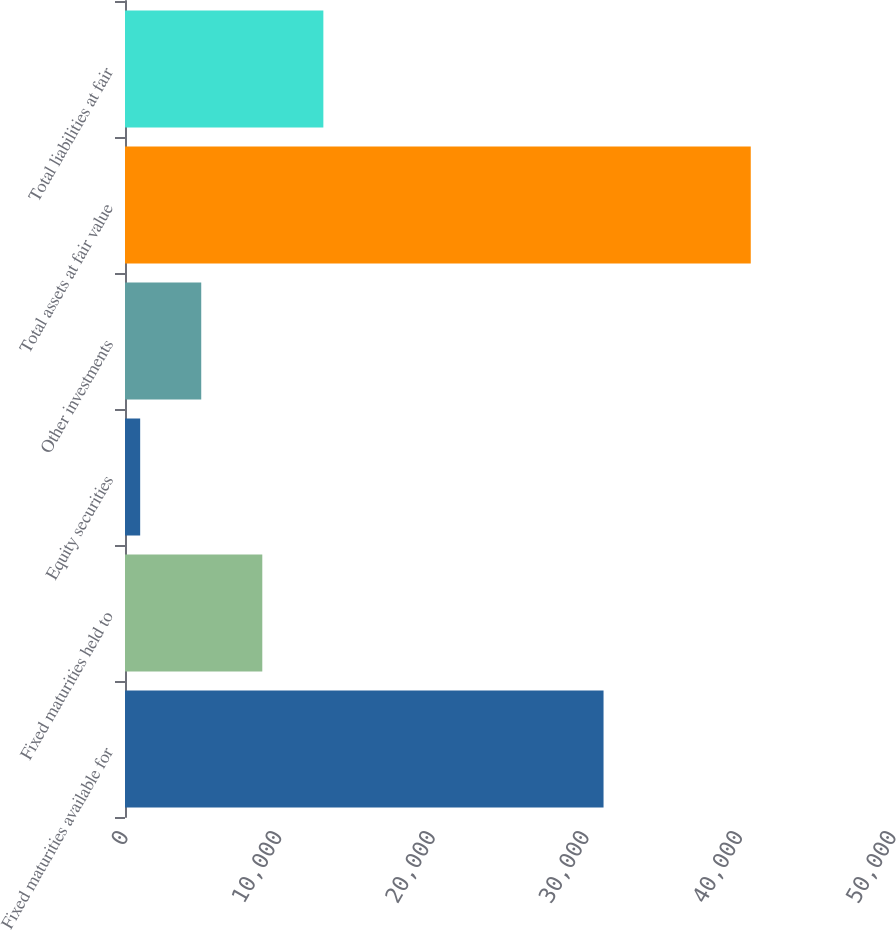Convert chart. <chart><loc_0><loc_0><loc_500><loc_500><bar_chart><fcel>Fixed maturities available for<fcel>Fixed maturities held to<fcel>Equity securities<fcel>Other investments<fcel>Total assets at fair value<fcel>Total liabilities at fair<nl><fcel>31155<fcel>8938.4<fcel>988<fcel>4963.2<fcel>40740<fcel>12913.6<nl></chart> 